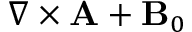<formula> <loc_0><loc_0><loc_500><loc_500>\nabla \times { \mathbf A } + { \mathbf B } _ { 0 }</formula> 